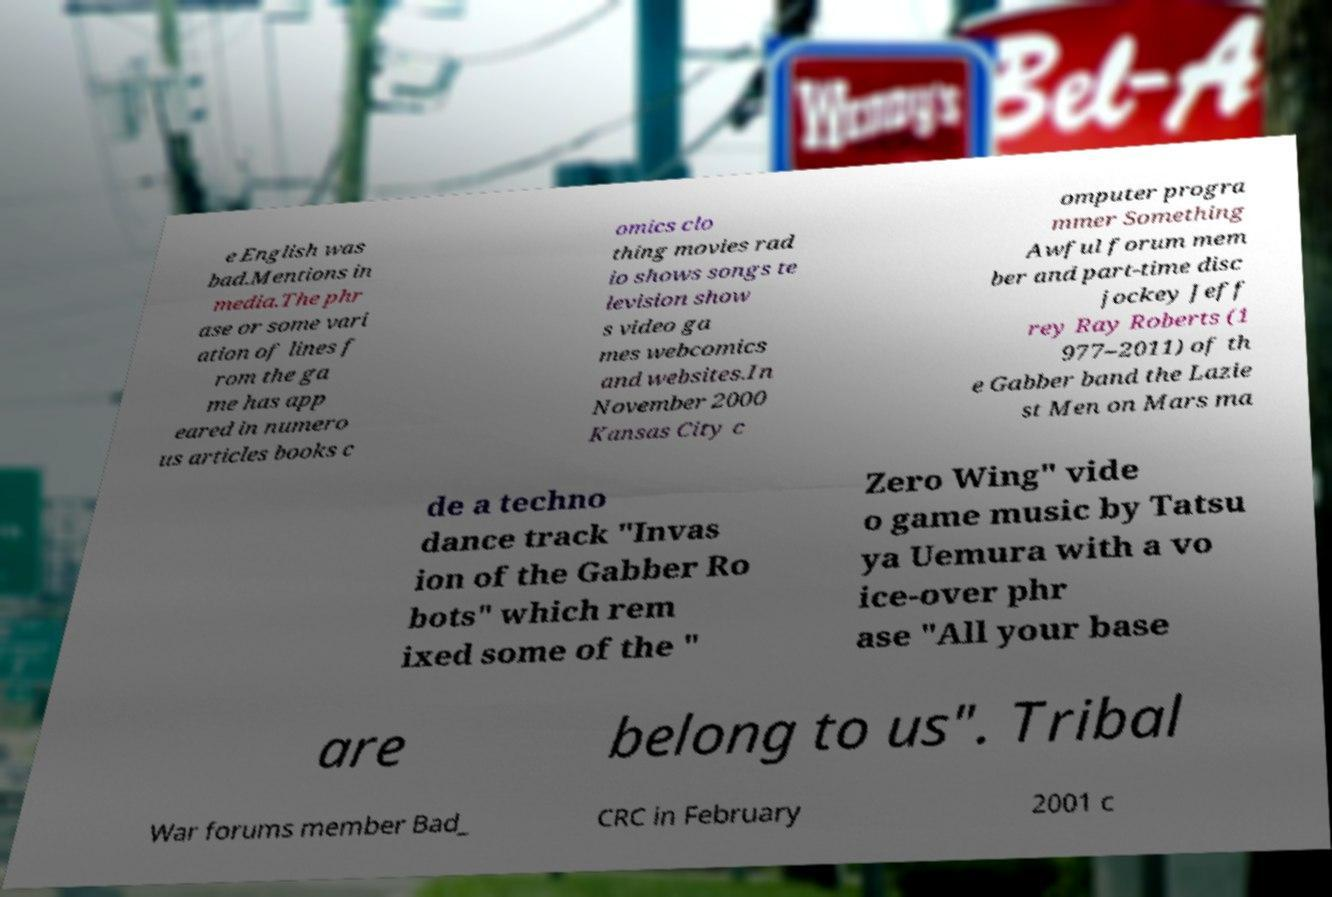There's text embedded in this image that I need extracted. Can you transcribe it verbatim? e English was bad.Mentions in media.The phr ase or some vari ation of lines f rom the ga me has app eared in numero us articles books c omics clo thing movies rad io shows songs te levision show s video ga mes webcomics and websites.In November 2000 Kansas City c omputer progra mmer Something Awful forum mem ber and part-time disc jockey Jeff rey Ray Roberts (1 977–2011) of th e Gabber band the Lazie st Men on Mars ma de a techno dance track "Invas ion of the Gabber Ro bots" which rem ixed some of the " Zero Wing" vide o game music by Tatsu ya Uemura with a vo ice-over phr ase "All your base are belong to us". Tribal War forums member Bad_ CRC in February 2001 c 